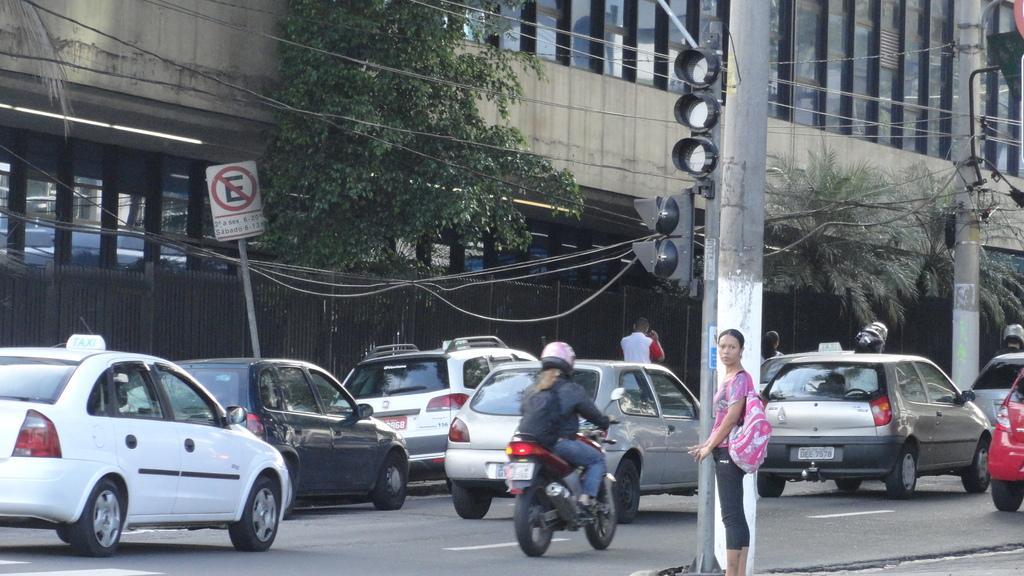Please provide a concise description of this image. In this image there is a road. On the road there are vehicles. There is a lady holding bag and standing. Near to her there is a pillar. Also there are traffic signals with pole. In the back there are railings. Also there are poles. There is a sign board with a pole. Also there are wires. And there are trees and buildings. 